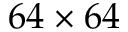Convert formula to latex. <formula><loc_0><loc_0><loc_500><loc_500>6 4 \times 6 4</formula> 